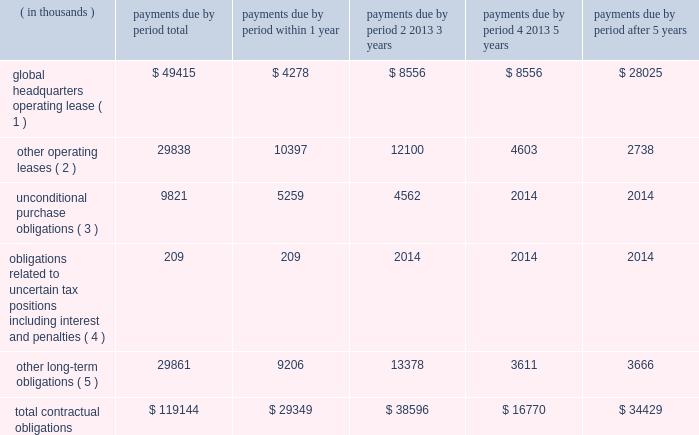Contractual obligations the company's significant contractual obligations as of december 31 , 2014 are summarized below: .
( 1 ) on september 14 , 2012 , the company entered into a lease agreement for 186000 square feet of rentable space located in an office facility in canonsburg , pennsylvania , which serves as the company's new headquarters .
The lease was effective as of september 14 , 2012 , but because the leased premises were under construction , the company was not obligated to pay rent until three months following the date that the leased premises were delivered to ansys , which occurred on october 1 , 2014 .
The term of the lease is 183 months , beginning on october 1 , 2014 .
The company shall have a one-time right to terminate the lease effective upon the last day of the tenth full year following the date of possession ( december 31 , 2024 ) , by providing the landlord with at least 18 months' prior written notice of such termination .
The company's lease for its prior headquarters expired on december 31 , 2014 .
( 2 ) other operating leases primarily include noncancellable lease commitments for the company 2019s other domestic and international offices as well as certain operating equipment .
( 3 ) unconditional purchase obligations primarily include software licenses and long-term purchase contracts for network , communication and office maintenance services , which are unrecorded as of december 31 , 2014 .
( 4 ) the company has $ 17.3 million of unrecognized tax benefits , including estimated interest and penalties , that have been recorded as liabilities in accordance with income tax accounting guidance for which the company is uncertain as to if or when such amounts may be settled .
As a result , such amounts are excluded from the table above .
( 5 ) other long-term obligations primarily include deferred compensation of $ 18.5 million ( including estimated imputed interest of $ 300000 within 1 year , $ 450000 within 2-3 years and $ 90000 within 4-5 years ) , pension obligations of $ 6.3 million for certain foreign locations of the company and contingent consideration of $ 2.8 million ( including estimated imputed interest of $ 270000 within 1 year and $ 390000 within 2-3 years ) .
Table of contents .
What percentage of total contractual obligations come from other operating leases? 
Computations: (29838 / 119144)
Answer: 0.25044. 